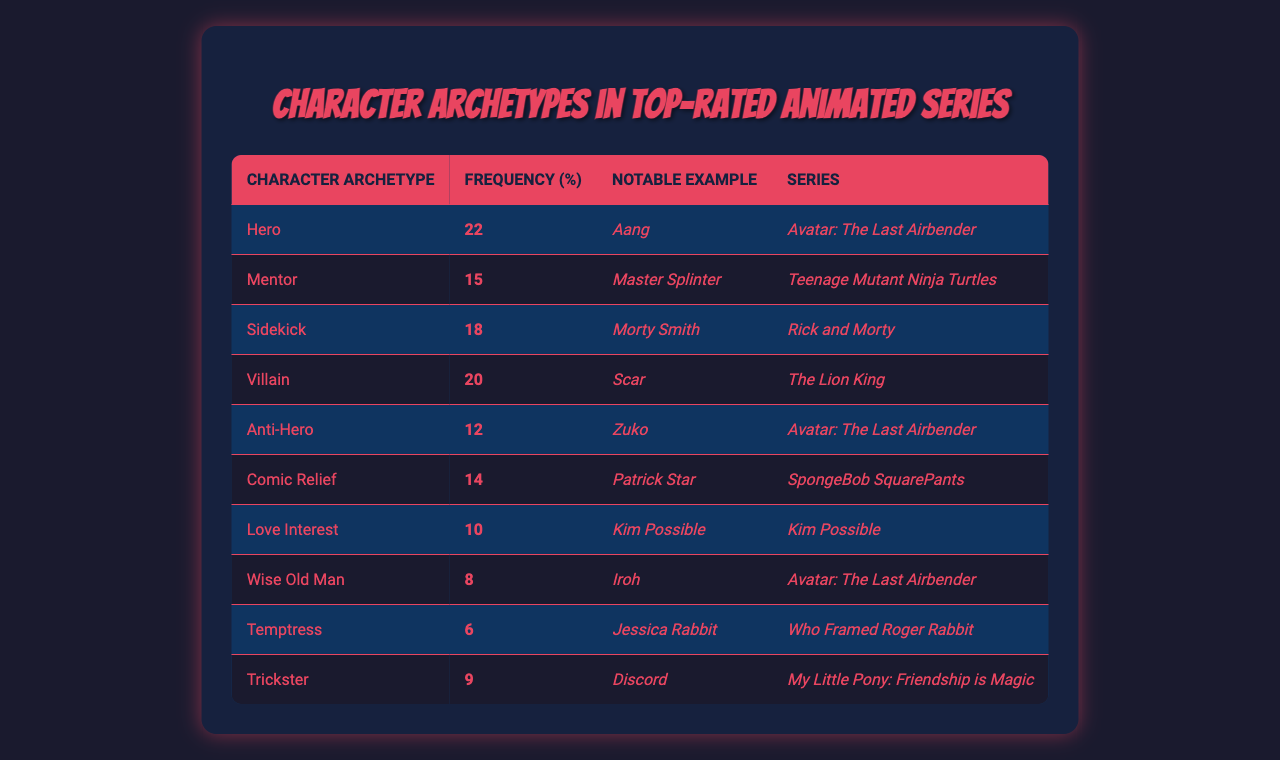What character archetype has the highest frequency in top-rated animated series? The table shows that the "Hero" archetype has the highest frequency at 22%.
Answer: Hero Which character is listed as the sidekick in the table? According to the table, the sidekick is Morty Smith from "Rick and Morty."
Answer: Morty Smith What percentage of the characters are classified as anti-heroes? The table indicates that the frequency of anti-heroes is 12%.
Answer: 12% Is the "Wise Old Man" archetype more or less frequent than the "Temptress"? The "Wise Old Man" has a frequency of 8%, while the "Temptress" has 6%, so it is more frequent.
Answer: More frequent What is the total frequency of villains and anti-heroes combined? Adding the frequencies of villains (20%) and anti-heroes (12%) gives a total of 32%.
Answer: 32% Which series features the character Iroh? The character Iroh is featured in "Avatar: The Last Airbender."
Answer: Avatar: The Last Airbender What percentage of characters are either mentors or comic relief? The "Mentor" has 15% and the "Comic Relief" has 14%, for a total of 29%.
Answer: 29% Do any characters represent the "Love Interest" archetype in the series? Yes, the table lists Kim Possible as a love interest in the series "Kim Possible."
Answer: Yes Which archetypes have a frequency of less than 10%? The "Wise Old Man" (8%) and "Temptress" (6%) have a frequency of less than 10%.
Answer: Wise Old Man and Temptress What is the difference in frequency between the "Hero" and "Villain" archetypes? The "Hero" archetype has a frequency of 22%, while the "Villain" has 20%, making the difference 2%.
Answer: 2% 